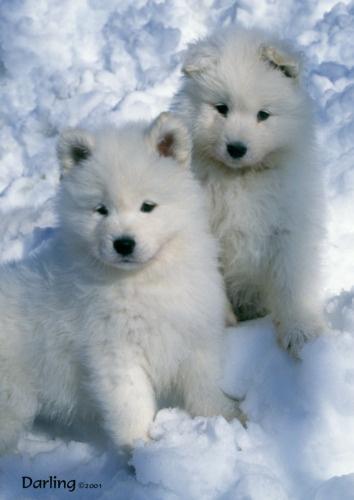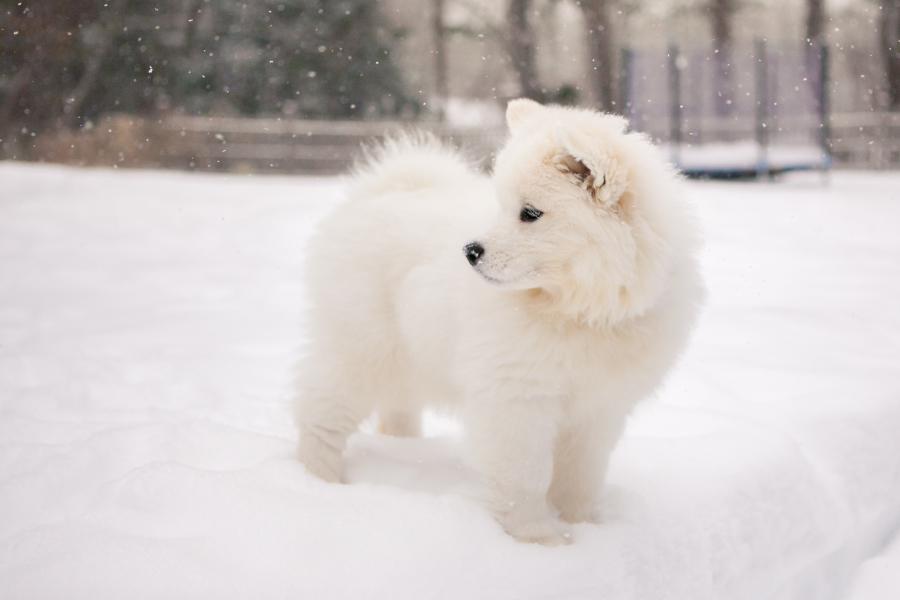The first image is the image on the left, the second image is the image on the right. For the images shown, is this caption "There are exactly three dogs." true? Answer yes or no. Yes. The first image is the image on the left, the second image is the image on the right. Considering the images on both sides, is "One image shows two white dogs close together in the snow, and the other shows a single white dog in a snowy scene." valid? Answer yes or no. Yes. 